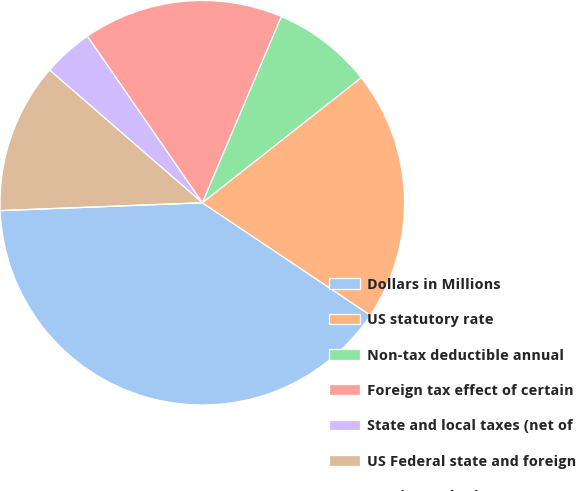Convert chart. <chart><loc_0><loc_0><loc_500><loc_500><pie_chart><fcel>Dollars in Millions<fcel>US statutory rate<fcel>Non-tax deductible annual<fcel>Foreign tax effect of certain<fcel>State and local taxes (net of<fcel>US Federal state and foreign<fcel>Foreign and other<nl><fcel>39.99%<fcel>20.0%<fcel>8.0%<fcel>16.0%<fcel>4.0%<fcel>12.0%<fcel>0.0%<nl></chart> 